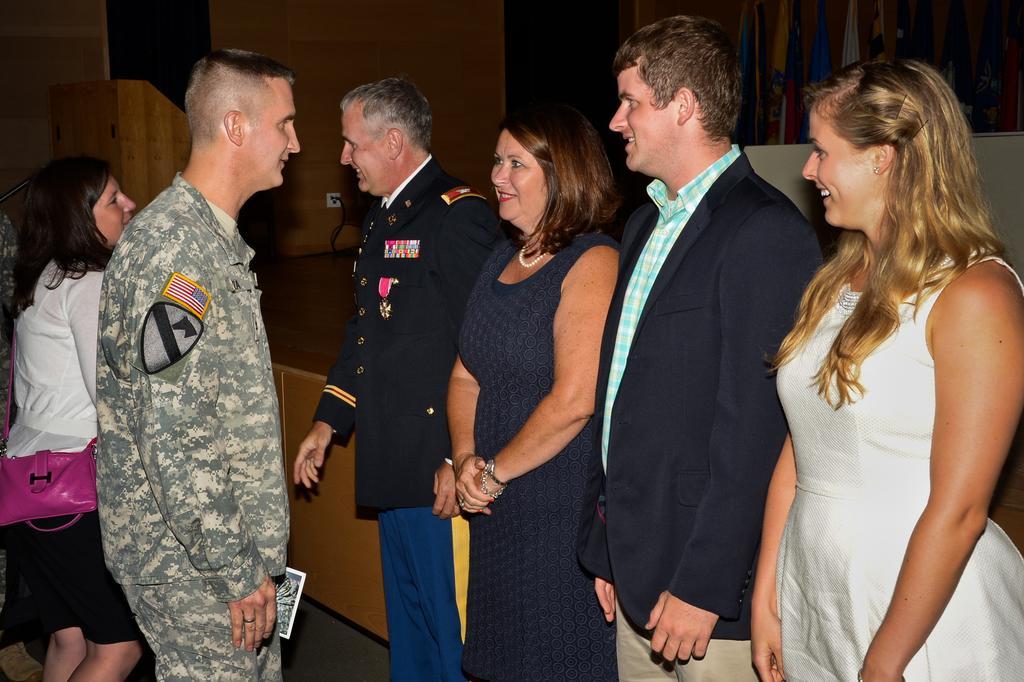How would you summarize this image in a sentence or two? On the left side of the image there is a man with uniform and badges on his hand is standing. Beside him there is a lady with black and white dress and with pink wallet is standing. In front of them there are few people standing. Behind them there is a stage with a table, flags and podium. In the background on the wall there is a plug board with wire. 